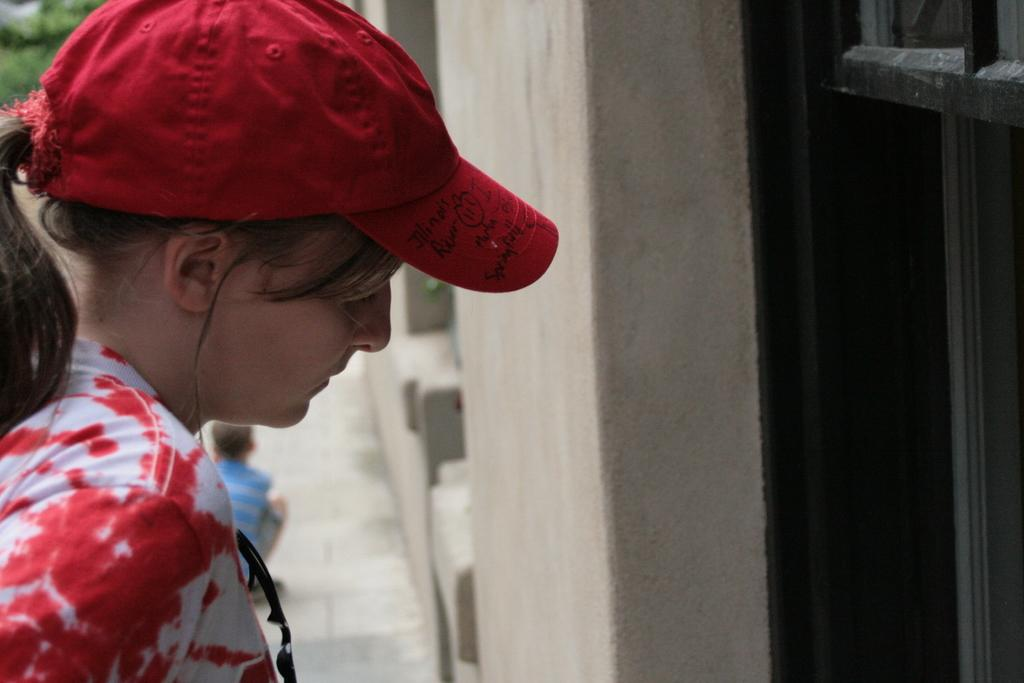Who or what is present in the image? There is a person in the image. What is the person wearing on their head? The person is wearing a cap. Where is the person standing in relation to the door? The person is standing in front of a door. What type of meat is being washed in the image? There is no meat or washing activity present in the image. 